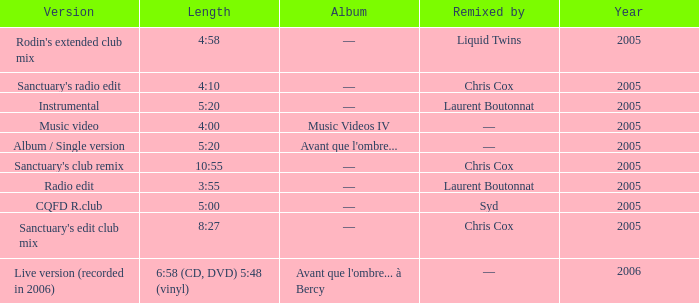What is the version shown for the Length of 4:58? Rodin's extended club mix. 